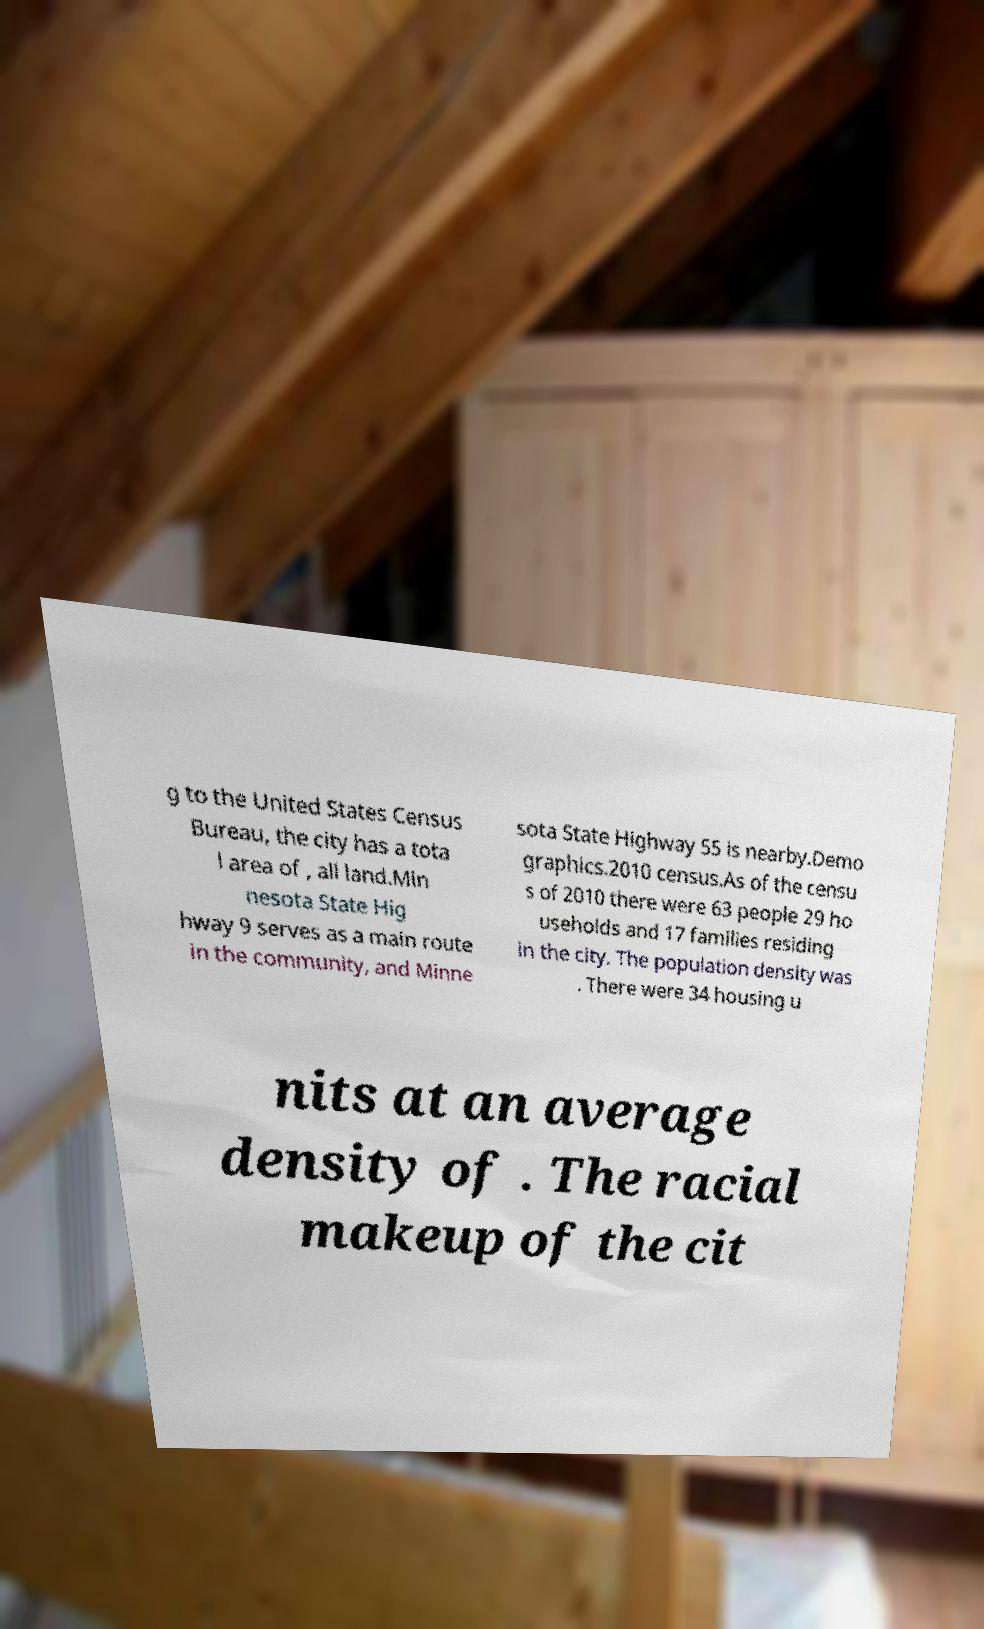Please identify and transcribe the text found in this image. g to the United States Census Bureau, the city has a tota l area of , all land.Min nesota State Hig hway 9 serves as a main route in the community, and Minne sota State Highway 55 is nearby.Demo graphics.2010 census.As of the censu s of 2010 there were 63 people 29 ho useholds and 17 families residing in the city. The population density was . There were 34 housing u nits at an average density of . The racial makeup of the cit 